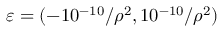<formula> <loc_0><loc_0><loc_500><loc_500>\varepsilon = ( - 1 0 ^ { - 1 0 } / \rho ^ { 2 } , 1 0 ^ { - 1 0 } / \rho ^ { 2 } )</formula> 